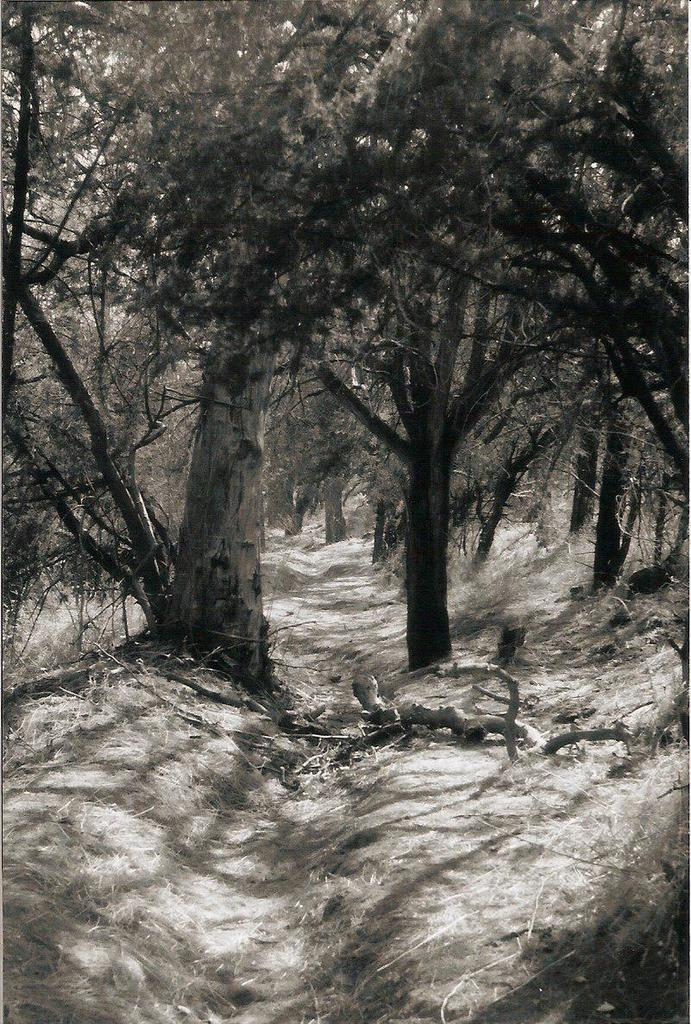What type of vegetation is predominant in the image? There are many trees in the image. What is the condition of the grass in the image? The land is covered with dry grass. What color is the silver hair of the person in the image? There is no person with silver hair present in the image; it features many trees and dry grass. 